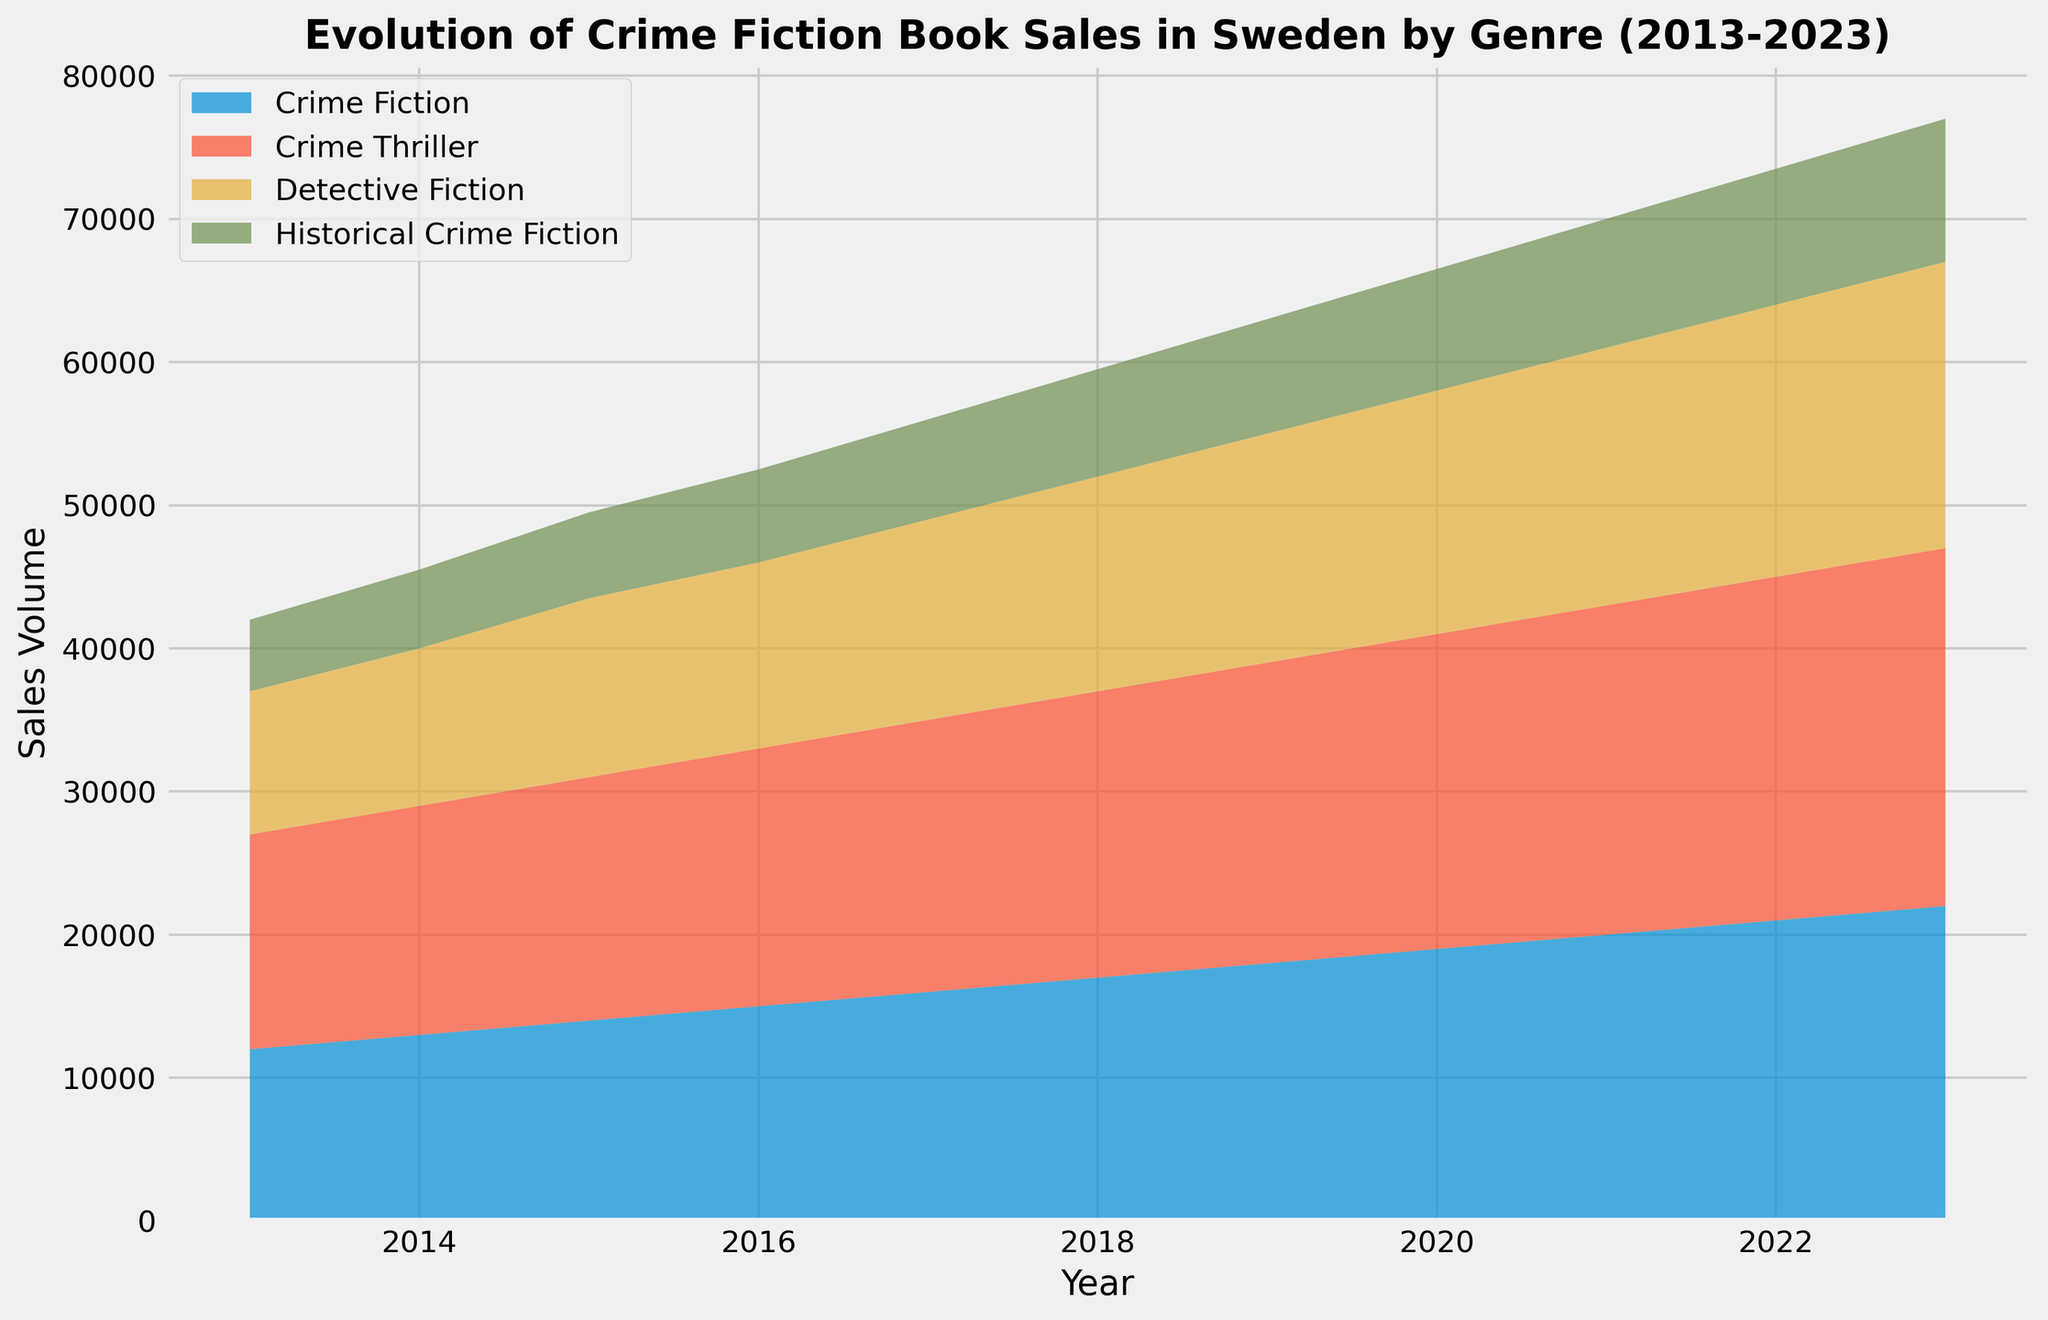What is the overall trend in Crime Fiction book sales from 2013 to 2023? The area representing Crime Fiction increases gradually over time, reflecting a consistent rise in sales.
Answer: Increasing Which genre had the highest sales volume in 2023? The topmost layer of the area chart for 2023 is Crime Thriller, indicating it had the highest sales.
Answer: Crime Thriller In which year did Detective Fiction book sales first exceed 15,000? Looking for when the second layer in the stack first crosses 15,000, it occurs in 2018.
Answer: 2018 What was the sales volume difference between Crime Fiction and Historical Crime Fiction in 2020? The height difference between the bottom layer (Crime Fiction at 19,000) and the top edge of the fourth layer (Historical Crime Fiction at 8,500) is 19,000 - 8,500 = 10,500.
Answer: 10,500 Calculate the average sales volume of Historical Crime Fiction between 2013 and 2023. Adding yearly sales (5,000 + 5,500 + 6,000 + 6,500 + 7,000 + 7,500 + 8,000 + 8,500 + 9,000 + 9,500 + 10,000) gives 83,500, divided by 11 years gives 7,590.91.
Answer: 7,590.91 Which genre had the smallest initial sales volume in 2013, and what was it? The smallest initial area is Historical Crime Fiction with 5,000 sales.
Answer: Historical Crime Fiction, 5,000 Did sales of Crime Thriller always remain higher than Detective Fiction throughout the decade? The area representing Crime Thriller is always above Detective Fiction across the entire chart.
Answer: Yes What is the total combined sales volume for all genres in 2019? Summing sales volumes from each genre in 2019: 18,000 + 21,000 + 16,000 + 8,000 = 63,000.
Answer: 63,000 Between which consecutive years did Crime Fiction see its highest annual increase in sales? The most significant upward shift in the Crime Fiction layer occurs between 2022 and 2023 (21,000 to 22,000).
Answer: 2022 to 2023 How much more did Crime Thriller sell than Historical Crime Fiction in 2023? Sales for Crime Thriller (25,000) minus sales for Historical Crime Fiction (10,000) equals 15,000.
Answer: 15,000 